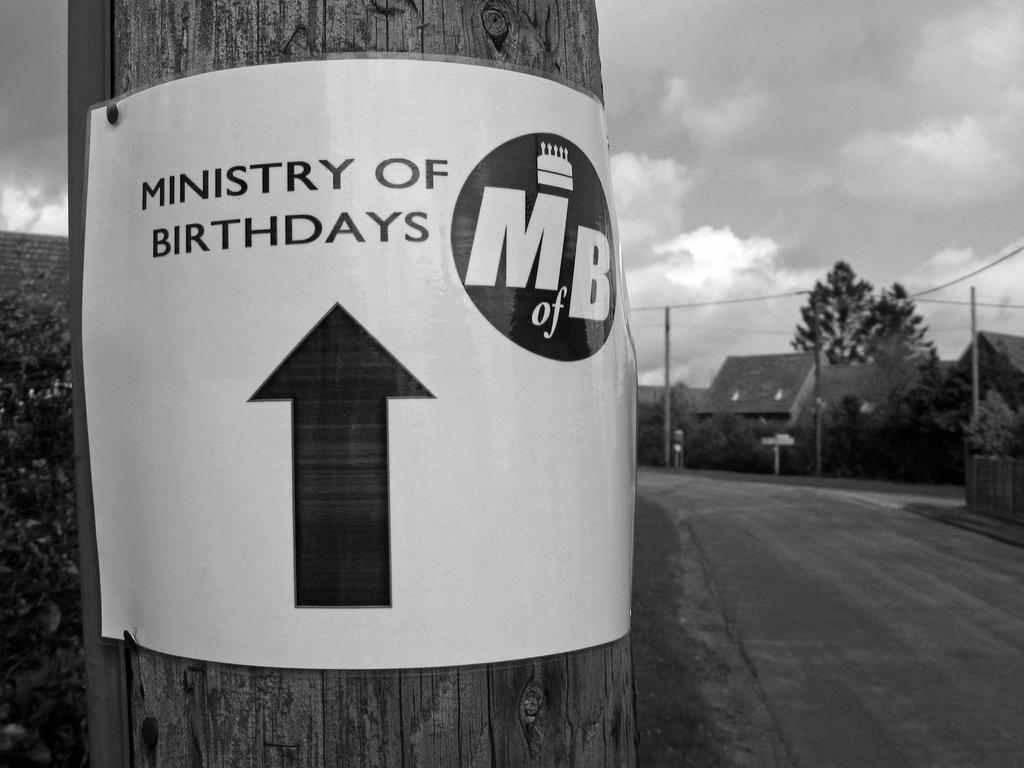<image>
Share a concise interpretation of the image provided. A white poster with the statement "Ministry of Birthdays" and an arrow pointed straight ahead affixed to a utility pole. 